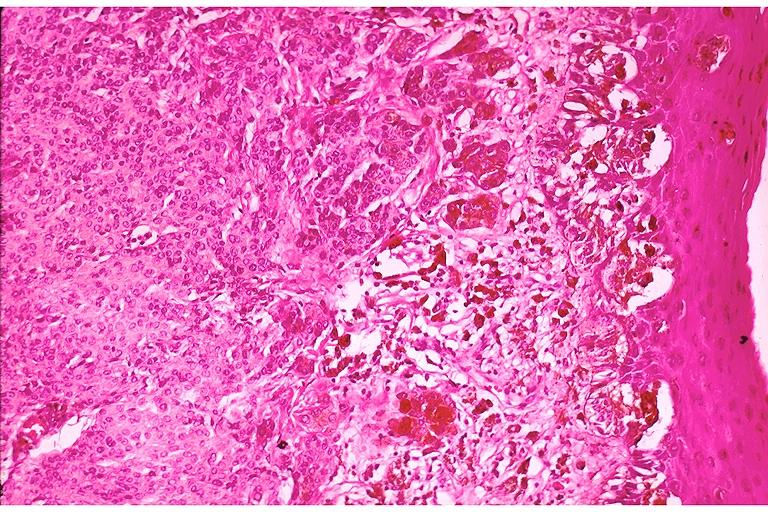does this image show compound nevus?
Answer the question using a single word or phrase. Yes 